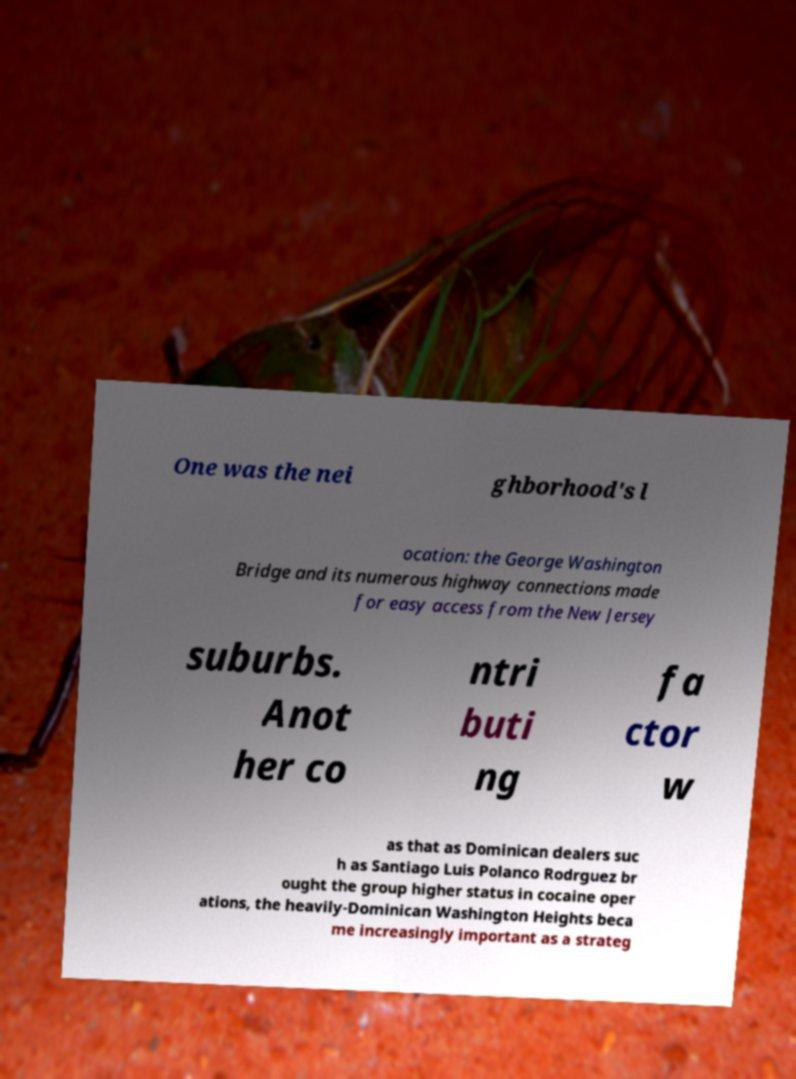Can you read and provide the text displayed in the image?This photo seems to have some interesting text. Can you extract and type it out for me? One was the nei ghborhood's l ocation: the George Washington Bridge and its numerous highway connections made for easy access from the New Jersey suburbs. Anot her co ntri buti ng fa ctor w as that as Dominican dealers suc h as Santiago Luis Polanco Rodrguez br ought the group higher status in cocaine oper ations, the heavily-Dominican Washington Heights beca me increasingly important as a strateg 